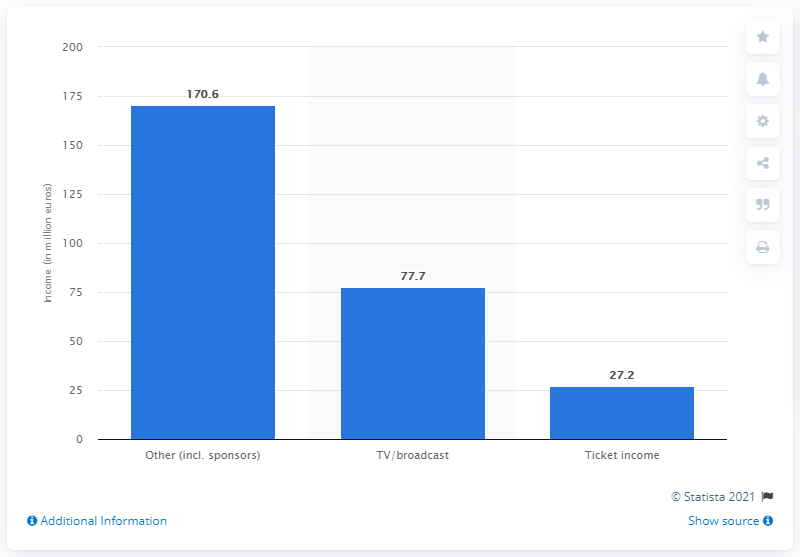Point out several critical features in this image. The total income from ticketing of all 22 clubs in Italy in the 2011/2012 season was 27.2 million euros. 